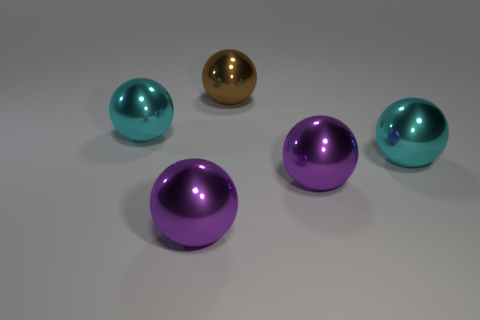What number of other things are there of the same shape as the big brown shiny thing?
Offer a terse response. 4. What number of other large brown spheres are the same material as the brown ball?
Keep it short and to the point. 0. There is a large cyan metal object that is left of the brown metallic thing; is its shape the same as the brown metallic thing?
Give a very brief answer. Yes. How many things are big purple shiny spheres to the right of the large brown ball or big purple metallic things?
Keep it short and to the point. 2. Are there any cyan objects of the same shape as the brown shiny thing?
Provide a short and direct response. Yes. Does the brown metal object have the same shape as the big cyan object right of the brown metallic object?
Ensure brevity in your answer.  Yes. How many large things are either brown things or purple metallic balls?
Your response must be concise. 3. Are there any gray metallic objects that have the same size as the brown object?
Your answer should be very brief. No. There is a large metallic thing behind the cyan shiny sphere to the left of the large purple shiny ball left of the big brown sphere; what color is it?
Ensure brevity in your answer.  Brown. What number of other objects are the same material as the brown thing?
Your response must be concise. 4. 